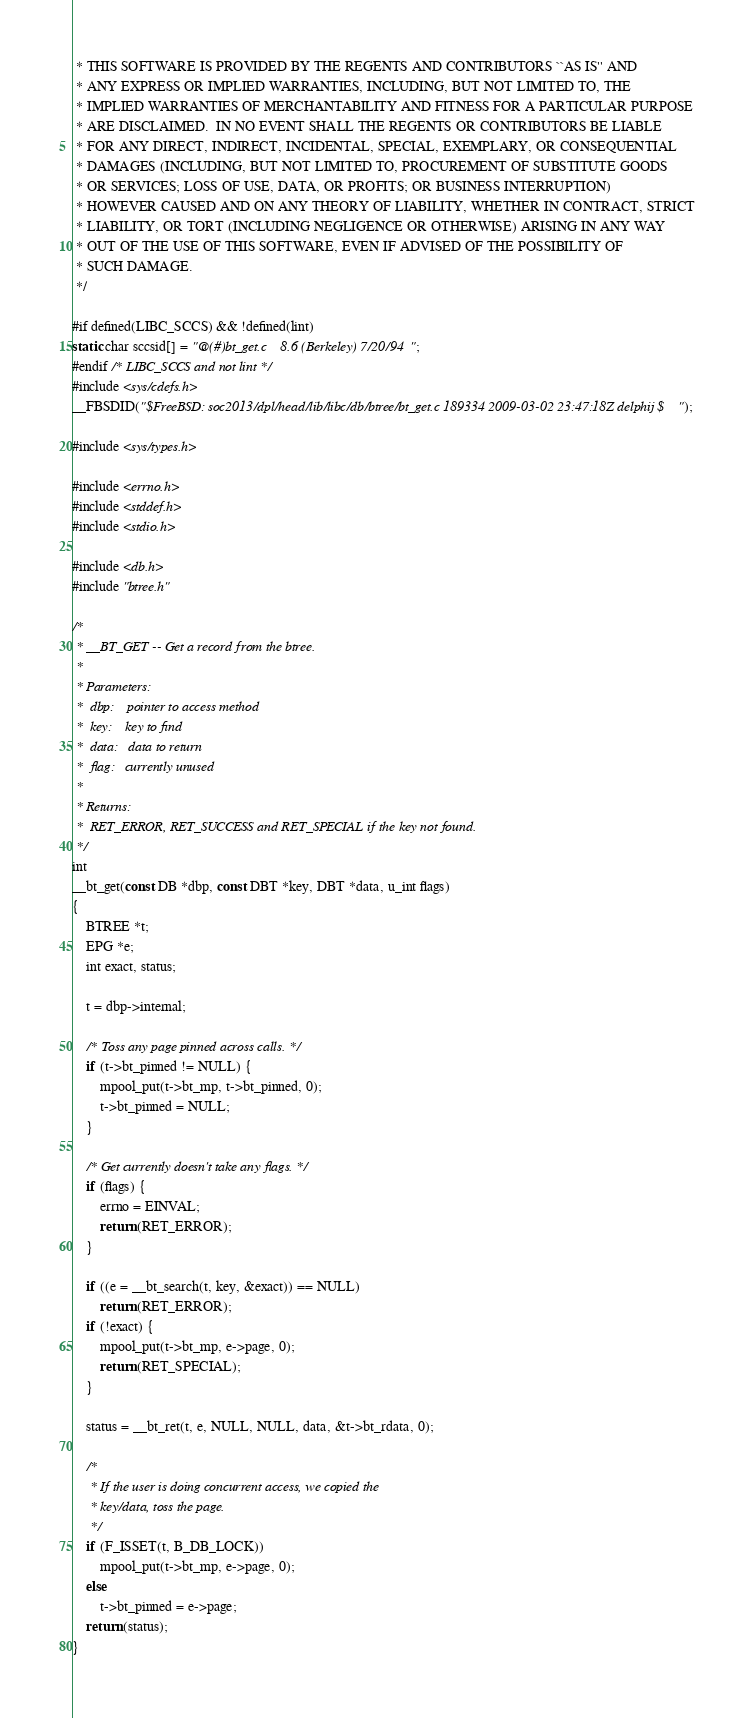<code> <loc_0><loc_0><loc_500><loc_500><_C_> * THIS SOFTWARE IS PROVIDED BY THE REGENTS AND CONTRIBUTORS ``AS IS'' AND
 * ANY EXPRESS OR IMPLIED WARRANTIES, INCLUDING, BUT NOT LIMITED TO, THE
 * IMPLIED WARRANTIES OF MERCHANTABILITY AND FITNESS FOR A PARTICULAR PURPOSE
 * ARE DISCLAIMED.  IN NO EVENT SHALL THE REGENTS OR CONTRIBUTORS BE LIABLE
 * FOR ANY DIRECT, INDIRECT, INCIDENTAL, SPECIAL, EXEMPLARY, OR CONSEQUENTIAL
 * DAMAGES (INCLUDING, BUT NOT LIMITED TO, PROCUREMENT OF SUBSTITUTE GOODS
 * OR SERVICES; LOSS OF USE, DATA, OR PROFITS; OR BUSINESS INTERRUPTION)
 * HOWEVER CAUSED AND ON ANY THEORY OF LIABILITY, WHETHER IN CONTRACT, STRICT
 * LIABILITY, OR TORT (INCLUDING NEGLIGENCE OR OTHERWISE) ARISING IN ANY WAY
 * OUT OF THE USE OF THIS SOFTWARE, EVEN IF ADVISED OF THE POSSIBILITY OF
 * SUCH DAMAGE.
 */

#if defined(LIBC_SCCS) && !defined(lint)
static char sccsid[] = "@(#)bt_get.c	8.6 (Berkeley) 7/20/94";
#endif /* LIBC_SCCS and not lint */
#include <sys/cdefs.h>
__FBSDID("$FreeBSD: soc2013/dpl/head/lib/libc/db/btree/bt_get.c 189334 2009-03-02 23:47:18Z delphij $");

#include <sys/types.h>

#include <errno.h>
#include <stddef.h>
#include <stdio.h>

#include <db.h>
#include "btree.h"

/*
 * __BT_GET -- Get a record from the btree.
 *
 * Parameters:
 *	dbp:	pointer to access method
 *	key:	key to find
 *	data:	data to return
 *	flag:	currently unused
 *
 * Returns:
 *	RET_ERROR, RET_SUCCESS and RET_SPECIAL if the key not found.
 */
int
__bt_get(const DB *dbp, const DBT *key, DBT *data, u_int flags)
{
	BTREE *t;
	EPG *e;
	int exact, status;

	t = dbp->internal;

	/* Toss any page pinned across calls. */
	if (t->bt_pinned != NULL) {
		mpool_put(t->bt_mp, t->bt_pinned, 0);
		t->bt_pinned = NULL;
	}

	/* Get currently doesn't take any flags. */
	if (flags) {
		errno = EINVAL;
		return (RET_ERROR);
	}

	if ((e = __bt_search(t, key, &exact)) == NULL)
		return (RET_ERROR);
	if (!exact) {
		mpool_put(t->bt_mp, e->page, 0);
		return (RET_SPECIAL);
	}

	status = __bt_ret(t, e, NULL, NULL, data, &t->bt_rdata, 0);

	/*
	 * If the user is doing concurrent access, we copied the
	 * key/data, toss the page.
	 */
	if (F_ISSET(t, B_DB_LOCK))
		mpool_put(t->bt_mp, e->page, 0);
	else
		t->bt_pinned = e->page;
	return (status);
}
</code> 